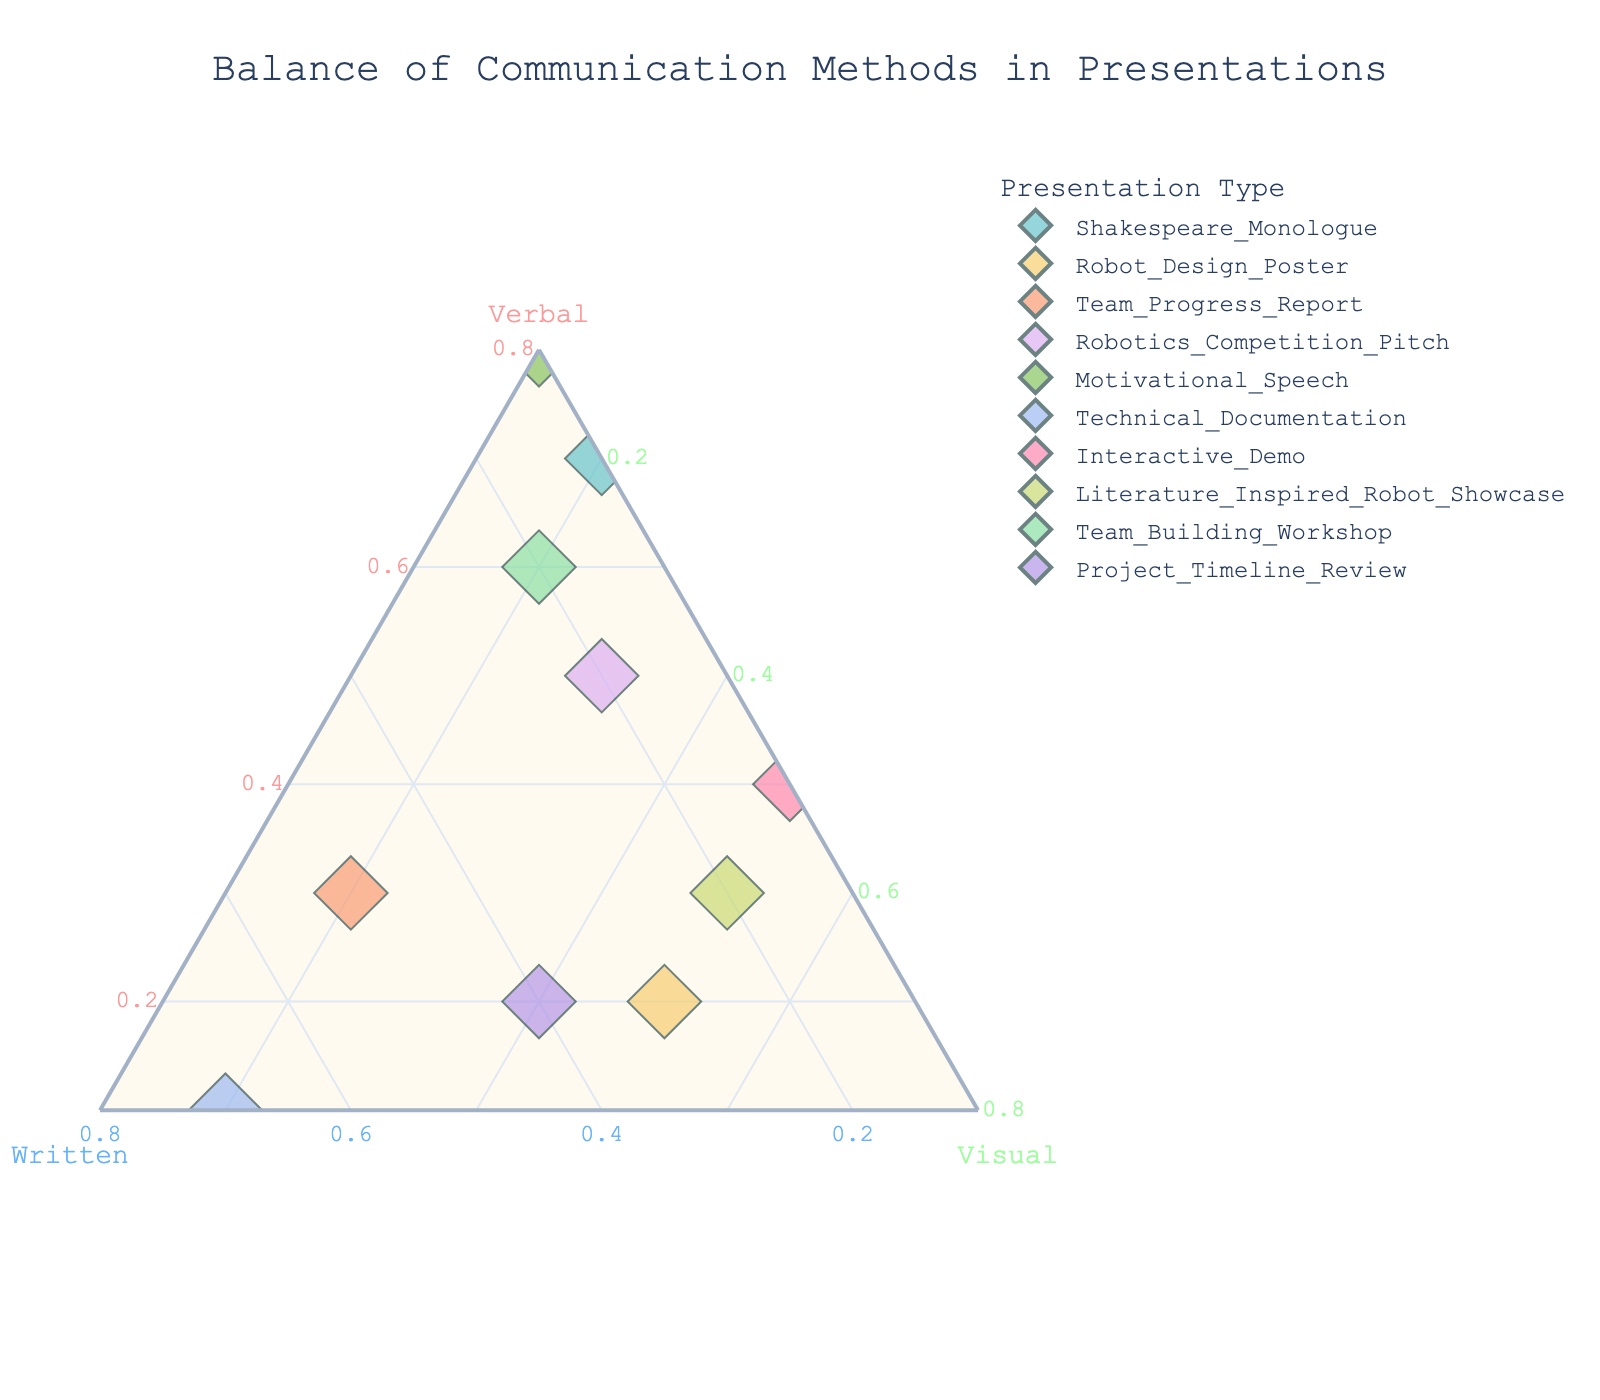Which presentation type has the highest emphasis on verbal communication? For this question, look for the data point closest to the vertex labeled "Verbal." The presentation with the highest verbal value is "Motivational Speech" with a verbal communication value of 0.8.
Answer: Motivational Speech How many data points are plotted? Examine the total number of unique markers displayed on the ternary plot, which corresponds to the different presentation types listed in the legend. Counting these, you will find 10 data points.
Answer: 10 Which presentation type has an equal balance between verbal and visual communication? Check the data points where the values for verbal and visual communication are the same. According to the plot, "Interactive Demo" has equal values of 0.4 for both verbal and visual communication.
Answer: Interactive Demo Which presentation type predominantly relies on written communication? Look for the data point closest to the vertex labeled "Written." The presentation with the highest written communication value is "Technical Documentation" with a value of 0.7.
Answer: Technical Documentation What is the color used for "Robotics Competition Pitch"? By examining the legend on the plot, you can identify the specific color assigned to "Robotics Competition Pitch." The color used for this presentation type is light blue.
Answer: Light blue For "Team Progress Report," which component has the highest value? Look at the location of the "Team Progress Report" data point. The component with the largest proportion closest to the respective axis is the "Written" communication, with a value of 0.5.
Answer: Written If you combine the visual and verbal values for "Robot Design Poster" and "Literature Inspired Robot Showcase," which has a higher combined value? For "Robot Design Poster": visual 0.5 + verbal 0.2 = 0.7. For "Literature Inspired Robot Showcase": visual 0.5 + verbal 0.3 = 0.8. Therefore, "Literature Inspired Robot Showcase" has a higher combined value.
Answer: Literature Inspired Robot Showcase Which presentations have verbal values greater than or equal to 0.5? Locate the data points where the verbal axis value is 0.5 or higher. "Shakespeare Monologue" (0.7), "Robotics Competition Pitch" (0.5), "Motivational Speech" (0.8), and "Team Building Workshop" (0.6) meet this criterion.
Answer: Shakespeare Monologue, Robotics Competition Pitch, Motivational Speech, Team Building Workshop 